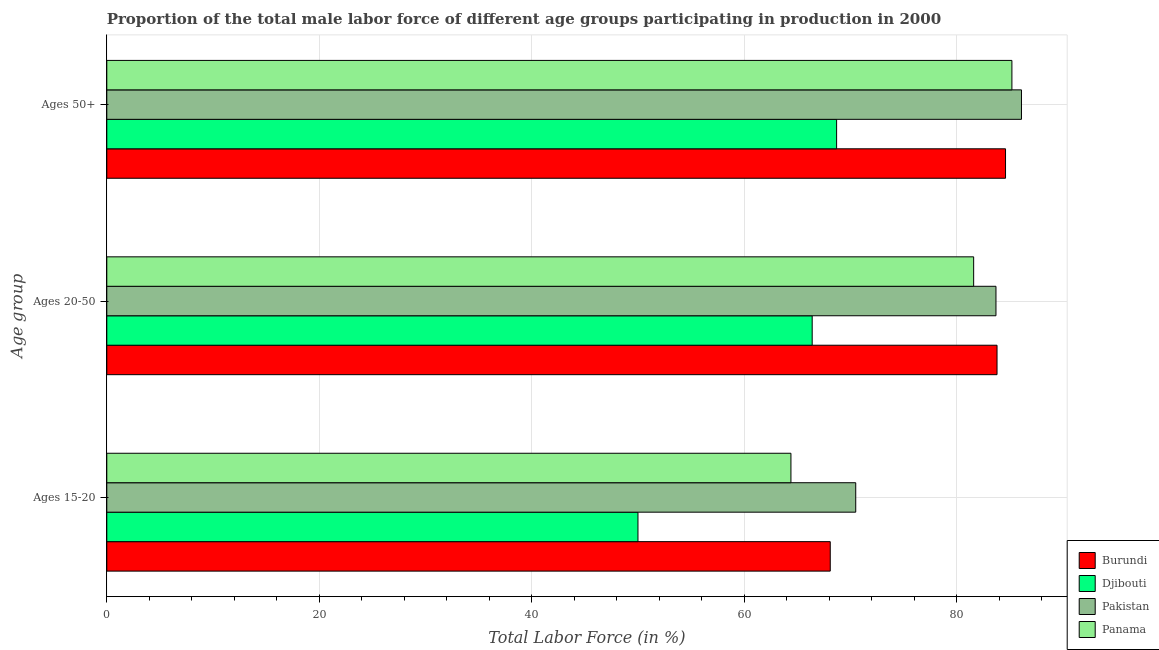Are the number of bars per tick equal to the number of legend labels?
Your answer should be very brief. Yes. What is the label of the 2nd group of bars from the top?
Your response must be concise. Ages 20-50. What is the percentage of male labor force within the age group 20-50 in Pakistan?
Offer a very short reply. 83.7. Across all countries, what is the maximum percentage of male labor force within the age group 20-50?
Offer a very short reply. 83.8. In which country was the percentage of male labor force above age 50 maximum?
Offer a terse response. Pakistan. In which country was the percentage of male labor force within the age group 15-20 minimum?
Ensure brevity in your answer.  Djibouti. What is the total percentage of male labor force within the age group 20-50 in the graph?
Provide a short and direct response. 315.5. What is the difference between the percentage of male labor force within the age group 15-20 in Panama and that in Pakistan?
Your answer should be very brief. -6.1. What is the difference between the percentage of male labor force above age 50 in Djibouti and the percentage of male labor force within the age group 20-50 in Panama?
Offer a terse response. -12.9. What is the average percentage of male labor force within the age group 15-20 per country?
Offer a terse response. 63.25. What is the difference between the percentage of male labor force within the age group 20-50 and percentage of male labor force above age 50 in Pakistan?
Offer a terse response. -2.4. What is the ratio of the percentage of male labor force above age 50 in Panama to that in Burundi?
Offer a very short reply. 1.01. Is the difference between the percentage of male labor force within the age group 20-50 in Panama and Djibouti greater than the difference between the percentage of male labor force above age 50 in Panama and Djibouti?
Your response must be concise. No. What is the difference between the highest and the second highest percentage of male labor force within the age group 15-20?
Your answer should be very brief. 2.4. In how many countries, is the percentage of male labor force within the age group 15-20 greater than the average percentage of male labor force within the age group 15-20 taken over all countries?
Give a very brief answer. 3. Is the sum of the percentage of male labor force above age 50 in Panama and Burundi greater than the maximum percentage of male labor force within the age group 15-20 across all countries?
Provide a succinct answer. Yes. What does the 3rd bar from the top in Ages 20-50 represents?
Make the answer very short. Djibouti. What does the 2nd bar from the bottom in Ages 20-50 represents?
Give a very brief answer. Djibouti. How many bars are there?
Make the answer very short. 12. Are all the bars in the graph horizontal?
Your answer should be compact. Yes. How many countries are there in the graph?
Your answer should be very brief. 4. What is the difference between two consecutive major ticks on the X-axis?
Give a very brief answer. 20. Are the values on the major ticks of X-axis written in scientific E-notation?
Offer a very short reply. No. Does the graph contain grids?
Your answer should be compact. Yes. How are the legend labels stacked?
Your response must be concise. Vertical. What is the title of the graph?
Your response must be concise. Proportion of the total male labor force of different age groups participating in production in 2000. Does "Vanuatu" appear as one of the legend labels in the graph?
Give a very brief answer. No. What is the label or title of the X-axis?
Provide a short and direct response. Total Labor Force (in %). What is the label or title of the Y-axis?
Give a very brief answer. Age group. What is the Total Labor Force (in %) of Burundi in Ages 15-20?
Keep it short and to the point. 68.1. What is the Total Labor Force (in %) of Djibouti in Ages 15-20?
Offer a terse response. 50. What is the Total Labor Force (in %) in Pakistan in Ages 15-20?
Keep it short and to the point. 70.5. What is the Total Labor Force (in %) of Panama in Ages 15-20?
Provide a short and direct response. 64.4. What is the Total Labor Force (in %) in Burundi in Ages 20-50?
Provide a succinct answer. 83.8. What is the Total Labor Force (in %) of Djibouti in Ages 20-50?
Keep it short and to the point. 66.4. What is the Total Labor Force (in %) of Pakistan in Ages 20-50?
Provide a succinct answer. 83.7. What is the Total Labor Force (in %) of Panama in Ages 20-50?
Ensure brevity in your answer.  81.6. What is the Total Labor Force (in %) of Burundi in Ages 50+?
Provide a succinct answer. 84.6. What is the Total Labor Force (in %) in Djibouti in Ages 50+?
Your answer should be compact. 68.7. What is the Total Labor Force (in %) in Pakistan in Ages 50+?
Keep it short and to the point. 86.1. What is the Total Labor Force (in %) of Panama in Ages 50+?
Your answer should be compact. 85.2. Across all Age group, what is the maximum Total Labor Force (in %) in Burundi?
Your response must be concise. 84.6. Across all Age group, what is the maximum Total Labor Force (in %) in Djibouti?
Provide a succinct answer. 68.7. Across all Age group, what is the maximum Total Labor Force (in %) of Pakistan?
Give a very brief answer. 86.1. Across all Age group, what is the maximum Total Labor Force (in %) of Panama?
Keep it short and to the point. 85.2. Across all Age group, what is the minimum Total Labor Force (in %) in Burundi?
Provide a short and direct response. 68.1. Across all Age group, what is the minimum Total Labor Force (in %) in Djibouti?
Provide a short and direct response. 50. Across all Age group, what is the minimum Total Labor Force (in %) of Pakistan?
Ensure brevity in your answer.  70.5. Across all Age group, what is the minimum Total Labor Force (in %) in Panama?
Your response must be concise. 64.4. What is the total Total Labor Force (in %) in Burundi in the graph?
Give a very brief answer. 236.5. What is the total Total Labor Force (in %) in Djibouti in the graph?
Give a very brief answer. 185.1. What is the total Total Labor Force (in %) of Pakistan in the graph?
Offer a very short reply. 240.3. What is the total Total Labor Force (in %) in Panama in the graph?
Give a very brief answer. 231.2. What is the difference between the Total Labor Force (in %) in Burundi in Ages 15-20 and that in Ages 20-50?
Keep it short and to the point. -15.7. What is the difference between the Total Labor Force (in %) in Djibouti in Ages 15-20 and that in Ages 20-50?
Your response must be concise. -16.4. What is the difference between the Total Labor Force (in %) in Panama in Ages 15-20 and that in Ages 20-50?
Provide a succinct answer. -17.2. What is the difference between the Total Labor Force (in %) of Burundi in Ages 15-20 and that in Ages 50+?
Ensure brevity in your answer.  -16.5. What is the difference between the Total Labor Force (in %) of Djibouti in Ages 15-20 and that in Ages 50+?
Provide a succinct answer. -18.7. What is the difference between the Total Labor Force (in %) in Pakistan in Ages 15-20 and that in Ages 50+?
Your response must be concise. -15.6. What is the difference between the Total Labor Force (in %) of Panama in Ages 15-20 and that in Ages 50+?
Your answer should be compact. -20.8. What is the difference between the Total Labor Force (in %) in Pakistan in Ages 20-50 and that in Ages 50+?
Offer a terse response. -2.4. What is the difference between the Total Labor Force (in %) in Burundi in Ages 15-20 and the Total Labor Force (in %) in Pakistan in Ages 20-50?
Offer a very short reply. -15.6. What is the difference between the Total Labor Force (in %) in Burundi in Ages 15-20 and the Total Labor Force (in %) in Panama in Ages 20-50?
Give a very brief answer. -13.5. What is the difference between the Total Labor Force (in %) in Djibouti in Ages 15-20 and the Total Labor Force (in %) in Pakistan in Ages 20-50?
Provide a short and direct response. -33.7. What is the difference between the Total Labor Force (in %) in Djibouti in Ages 15-20 and the Total Labor Force (in %) in Panama in Ages 20-50?
Provide a short and direct response. -31.6. What is the difference between the Total Labor Force (in %) in Pakistan in Ages 15-20 and the Total Labor Force (in %) in Panama in Ages 20-50?
Provide a succinct answer. -11.1. What is the difference between the Total Labor Force (in %) in Burundi in Ages 15-20 and the Total Labor Force (in %) in Djibouti in Ages 50+?
Your answer should be compact. -0.6. What is the difference between the Total Labor Force (in %) of Burundi in Ages 15-20 and the Total Labor Force (in %) of Pakistan in Ages 50+?
Your answer should be very brief. -18. What is the difference between the Total Labor Force (in %) of Burundi in Ages 15-20 and the Total Labor Force (in %) of Panama in Ages 50+?
Your response must be concise. -17.1. What is the difference between the Total Labor Force (in %) in Djibouti in Ages 15-20 and the Total Labor Force (in %) in Pakistan in Ages 50+?
Give a very brief answer. -36.1. What is the difference between the Total Labor Force (in %) in Djibouti in Ages 15-20 and the Total Labor Force (in %) in Panama in Ages 50+?
Give a very brief answer. -35.2. What is the difference between the Total Labor Force (in %) of Pakistan in Ages 15-20 and the Total Labor Force (in %) of Panama in Ages 50+?
Give a very brief answer. -14.7. What is the difference between the Total Labor Force (in %) in Burundi in Ages 20-50 and the Total Labor Force (in %) in Djibouti in Ages 50+?
Provide a succinct answer. 15.1. What is the difference between the Total Labor Force (in %) of Burundi in Ages 20-50 and the Total Labor Force (in %) of Pakistan in Ages 50+?
Make the answer very short. -2.3. What is the difference between the Total Labor Force (in %) in Djibouti in Ages 20-50 and the Total Labor Force (in %) in Pakistan in Ages 50+?
Give a very brief answer. -19.7. What is the difference between the Total Labor Force (in %) in Djibouti in Ages 20-50 and the Total Labor Force (in %) in Panama in Ages 50+?
Provide a succinct answer. -18.8. What is the average Total Labor Force (in %) of Burundi per Age group?
Give a very brief answer. 78.83. What is the average Total Labor Force (in %) in Djibouti per Age group?
Your answer should be compact. 61.7. What is the average Total Labor Force (in %) of Pakistan per Age group?
Provide a succinct answer. 80.1. What is the average Total Labor Force (in %) of Panama per Age group?
Your answer should be very brief. 77.07. What is the difference between the Total Labor Force (in %) in Burundi and Total Labor Force (in %) in Pakistan in Ages 15-20?
Offer a terse response. -2.4. What is the difference between the Total Labor Force (in %) of Djibouti and Total Labor Force (in %) of Pakistan in Ages 15-20?
Provide a short and direct response. -20.5. What is the difference between the Total Labor Force (in %) of Djibouti and Total Labor Force (in %) of Panama in Ages 15-20?
Offer a very short reply. -14.4. What is the difference between the Total Labor Force (in %) of Pakistan and Total Labor Force (in %) of Panama in Ages 15-20?
Offer a terse response. 6.1. What is the difference between the Total Labor Force (in %) of Burundi and Total Labor Force (in %) of Panama in Ages 20-50?
Offer a terse response. 2.2. What is the difference between the Total Labor Force (in %) of Djibouti and Total Labor Force (in %) of Pakistan in Ages 20-50?
Your answer should be compact. -17.3. What is the difference between the Total Labor Force (in %) in Djibouti and Total Labor Force (in %) in Panama in Ages 20-50?
Ensure brevity in your answer.  -15.2. What is the difference between the Total Labor Force (in %) of Djibouti and Total Labor Force (in %) of Pakistan in Ages 50+?
Provide a short and direct response. -17.4. What is the difference between the Total Labor Force (in %) of Djibouti and Total Labor Force (in %) of Panama in Ages 50+?
Provide a succinct answer. -16.5. What is the difference between the Total Labor Force (in %) in Pakistan and Total Labor Force (in %) in Panama in Ages 50+?
Offer a very short reply. 0.9. What is the ratio of the Total Labor Force (in %) in Burundi in Ages 15-20 to that in Ages 20-50?
Give a very brief answer. 0.81. What is the ratio of the Total Labor Force (in %) in Djibouti in Ages 15-20 to that in Ages 20-50?
Offer a very short reply. 0.75. What is the ratio of the Total Labor Force (in %) of Pakistan in Ages 15-20 to that in Ages 20-50?
Give a very brief answer. 0.84. What is the ratio of the Total Labor Force (in %) in Panama in Ages 15-20 to that in Ages 20-50?
Offer a terse response. 0.79. What is the ratio of the Total Labor Force (in %) in Burundi in Ages 15-20 to that in Ages 50+?
Provide a succinct answer. 0.81. What is the ratio of the Total Labor Force (in %) of Djibouti in Ages 15-20 to that in Ages 50+?
Ensure brevity in your answer.  0.73. What is the ratio of the Total Labor Force (in %) of Pakistan in Ages 15-20 to that in Ages 50+?
Make the answer very short. 0.82. What is the ratio of the Total Labor Force (in %) in Panama in Ages 15-20 to that in Ages 50+?
Ensure brevity in your answer.  0.76. What is the ratio of the Total Labor Force (in %) of Burundi in Ages 20-50 to that in Ages 50+?
Provide a short and direct response. 0.99. What is the ratio of the Total Labor Force (in %) of Djibouti in Ages 20-50 to that in Ages 50+?
Keep it short and to the point. 0.97. What is the ratio of the Total Labor Force (in %) of Pakistan in Ages 20-50 to that in Ages 50+?
Your answer should be compact. 0.97. What is the ratio of the Total Labor Force (in %) in Panama in Ages 20-50 to that in Ages 50+?
Provide a short and direct response. 0.96. What is the difference between the highest and the second highest Total Labor Force (in %) in Burundi?
Provide a succinct answer. 0.8. What is the difference between the highest and the second highest Total Labor Force (in %) in Djibouti?
Keep it short and to the point. 2.3. What is the difference between the highest and the second highest Total Labor Force (in %) in Pakistan?
Your answer should be very brief. 2.4. What is the difference between the highest and the lowest Total Labor Force (in %) of Burundi?
Ensure brevity in your answer.  16.5. What is the difference between the highest and the lowest Total Labor Force (in %) of Djibouti?
Your response must be concise. 18.7. What is the difference between the highest and the lowest Total Labor Force (in %) in Pakistan?
Offer a terse response. 15.6. What is the difference between the highest and the lowest Total Labor Force (in %) in Panama?
Provide a short and direct response. 20.8. 